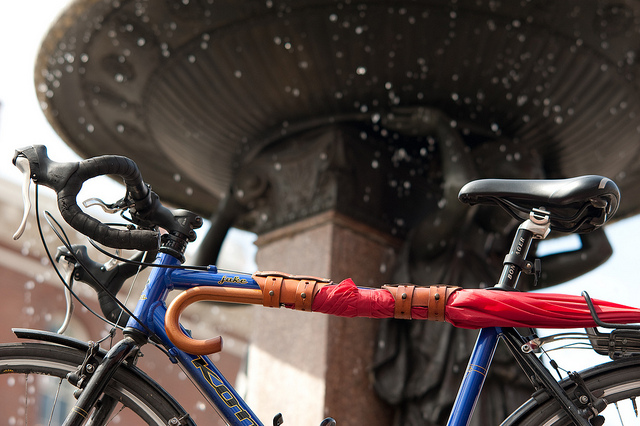Identify the text contained in this image. Ko 